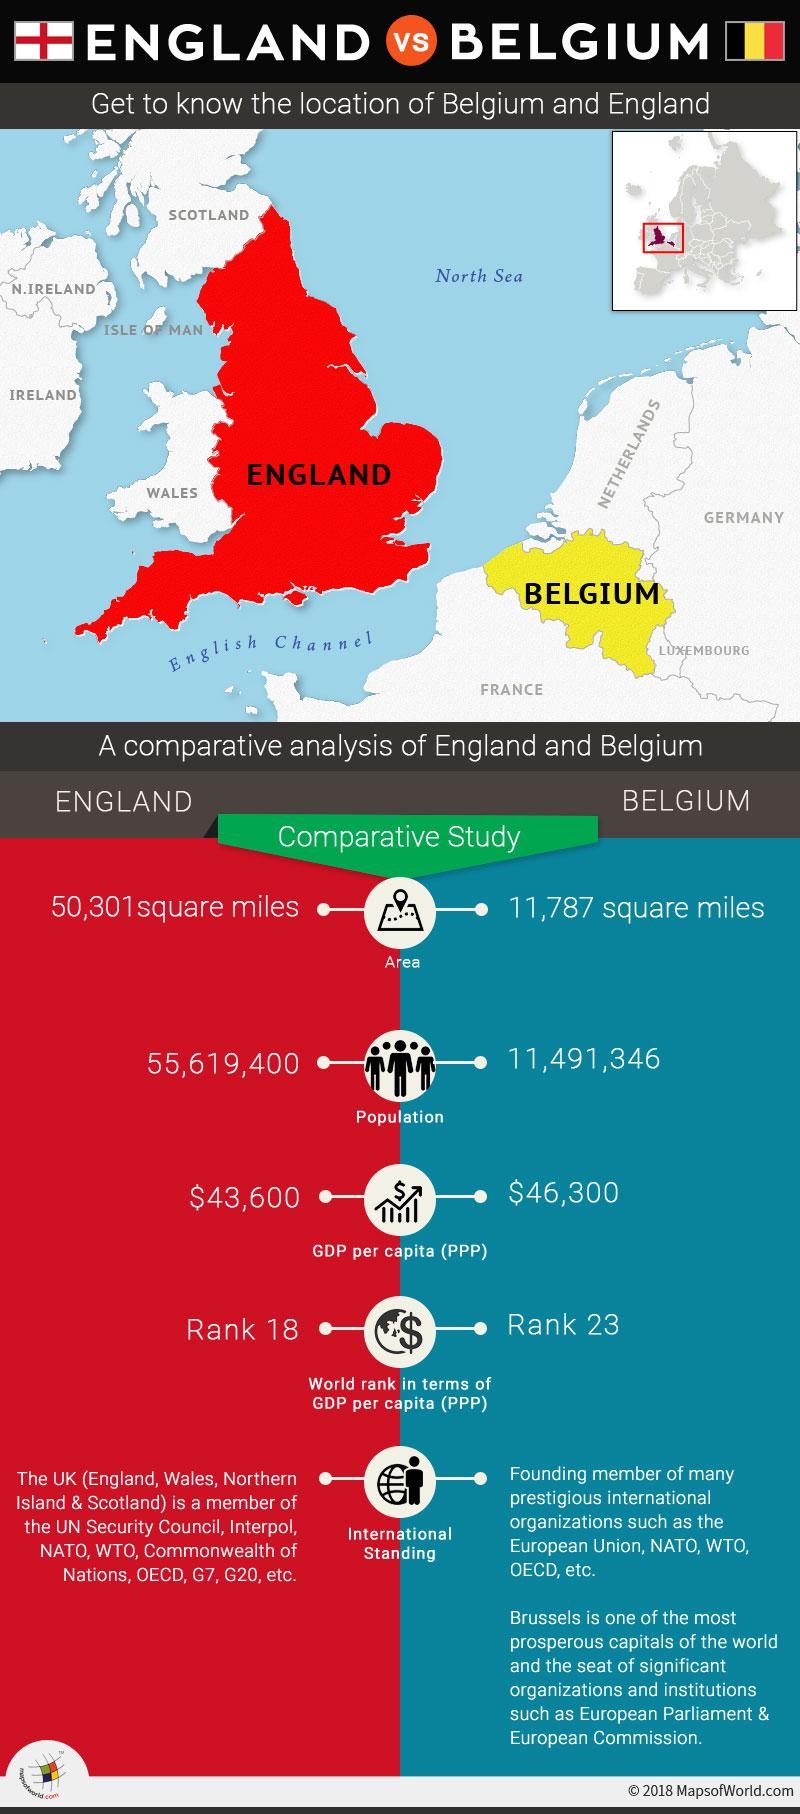Specify some key components in this picture. The English Channel is a water body located between France and England. France is located below Belgium. Belgium has a higher GDP than the country with the highest GDP. It is confirmed that England is depicted in red in the map. Belgium is shown in yellow in the image. 